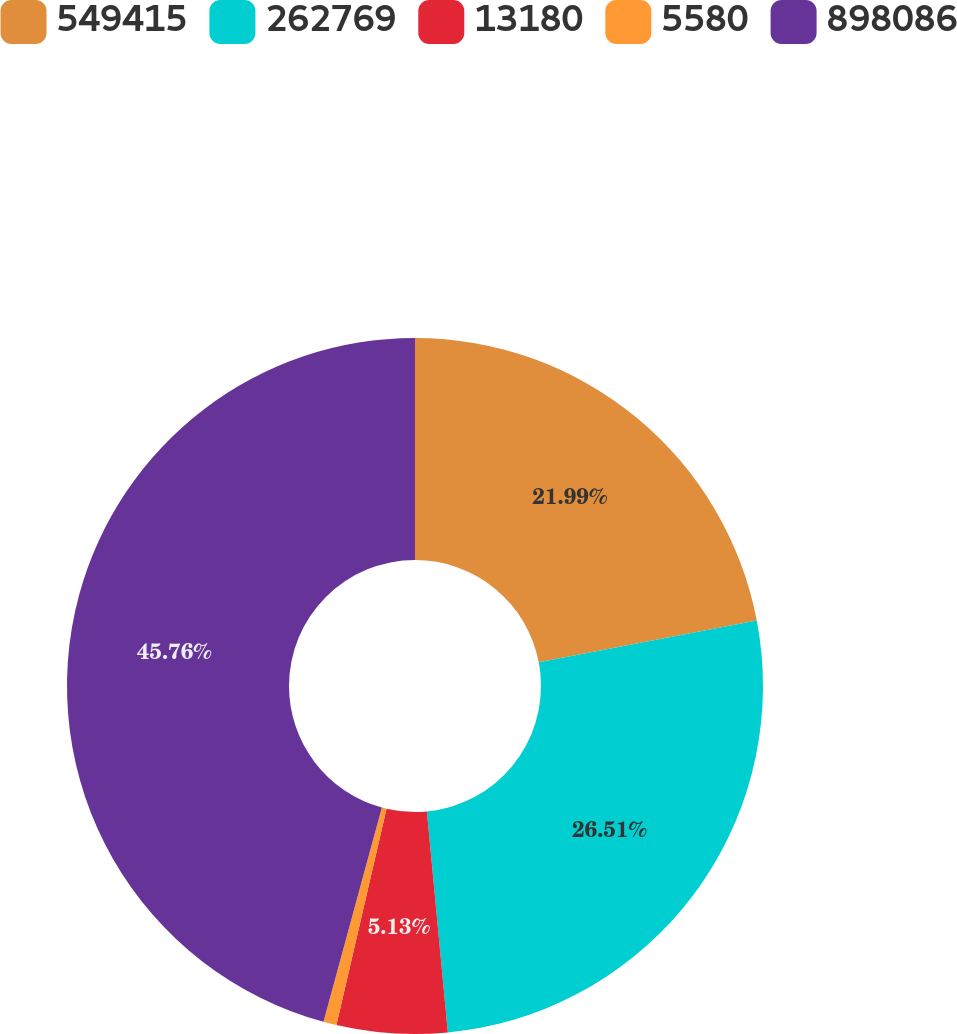<chart> <loc_0><loc_0><loc_500><loc_500><pie_chart><fcel>549415<fcel>262769<fcel>13180<fcel>5580<fcel>898086<nl><fcel>21.99%<fcel>26.51%<fcel>5.13%<fcel>0.61%<fcel>45.77%<nl></chart> 